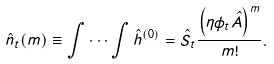<formula> <loc_0><loc_0><loc_500><loc_500>\hat { n } _ { t } ( m ) \equiv \int \cdots \int \hat { h } ^ { ( 0 ) } = \hat { S } _ { t } \frac { \left ( \eta \phi _ { t } \hat { A } \right ) ^ { m } } { m ! } .</formula> 